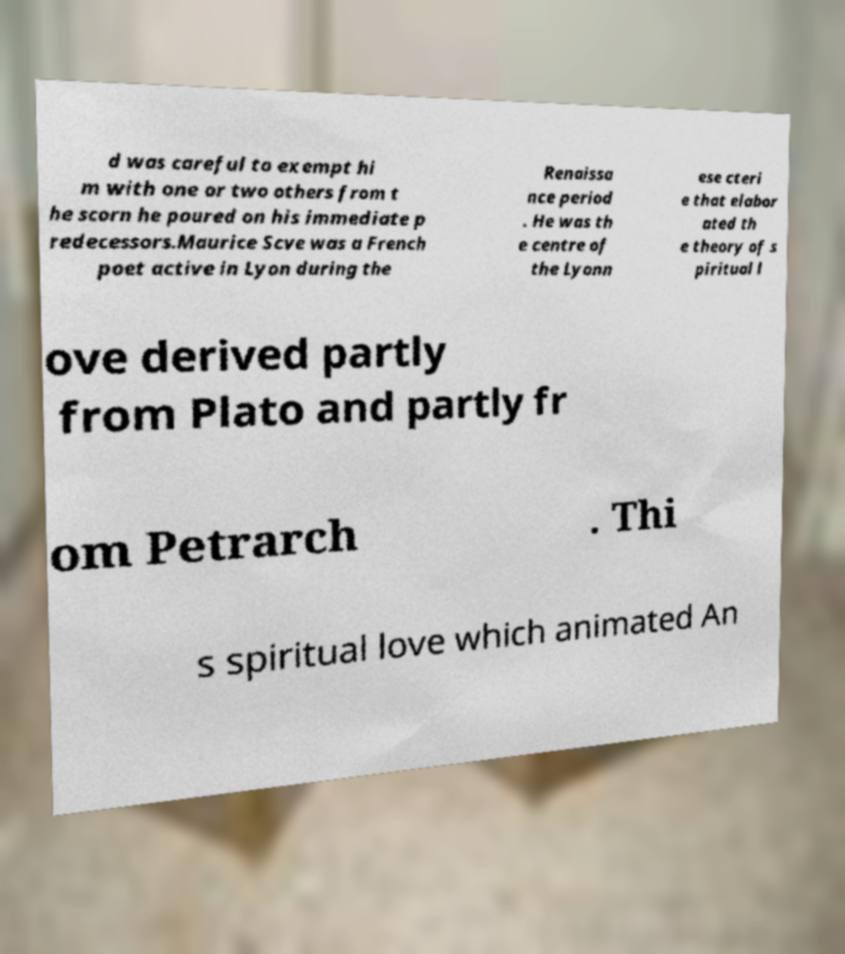Can you accurately transcribe the text from the provided image for me? d was careful to exempt hi m with one or two others from t he scorn he poured on his immediate p redecessors.Maurice Scve was a French poet active in Lyon during the Renaissa nce period . He was th e centre of the Lyonn ese cteri e that elabor ated th e theory of s piritual l ove derived partly from Plato and partly fr om Petrarch . Thi s spiritual love which animated An 